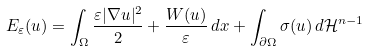<formula> <loc_0><loc_0><loc_500><loc_500>E _ { \varepsilon } ( u ) = \int _ { \Omega } \frac { \varepsilon | \nabla u | ^ { 2 } } { 2 } + \frac { W ( u ) } { \varepsilon } \, d x + \int _ { \partial \Omega } \sigma ( u ) \, d \mathcal { H } ^ { n - 1 }</formula> 